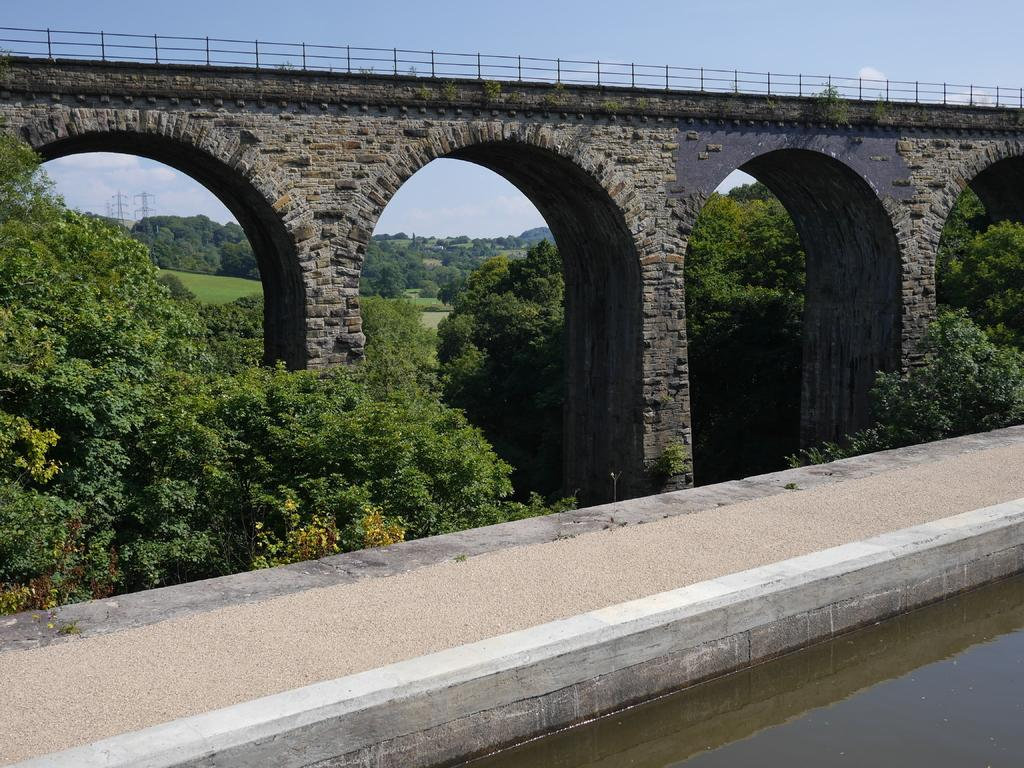What type of natural elements can be seen in the image? There are trees and plants in the image. What type of man-made structures are present in the image? There are towers and a bridge in the image. What is the water doing in the image? The water has a reflection in the image. What is visible in the sky in the image? The sky is visible in the image, and there are clouds in the sky. How many pickles are floating in the water in the image? There are no pickles present in the image; it features trees, plants, towers, a bridge, water with a reflection, and clouds in the sky. 